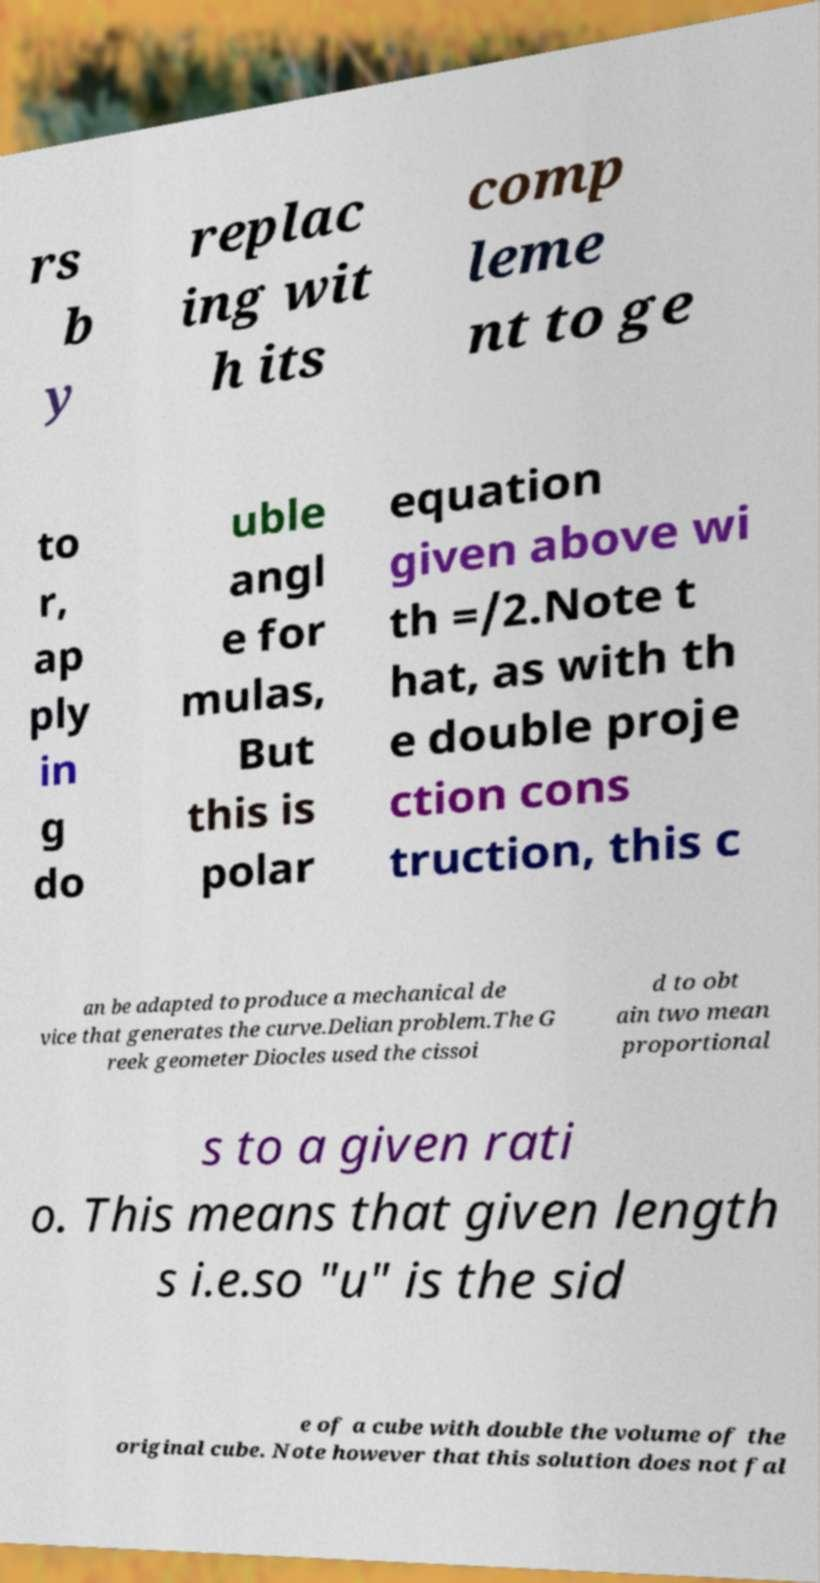Could you assist in decoding the text presented in this image and type it out clearly? rs b y replac ing wit h its comp leme nt to ge to r, ap ply in g do uble angl e for mulas, But this is polar equation given above wi th =/2.Note t hat, as with th e double proje ction cons truction, this c an be adapted to produce a mechanical de vice that generates the curve.Delian problem.The G reek geometer Diocles used the cissoi d to obt ain two mean proportional s to a given rati o. This means that given length s i.e.so "u" is the sid e of a cube with double the volume of the original cube. Note however that this solution does not fal 